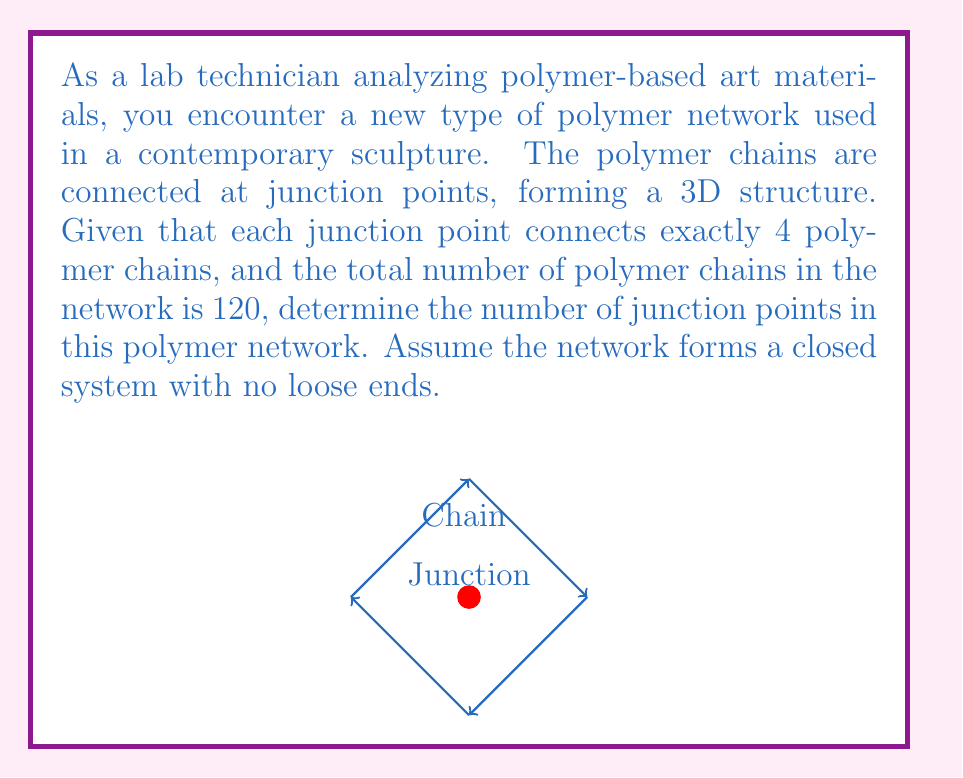Could you help me with this problem? To solve this problem, we need to use concepts from graph theory, which is closely related to topology. Let's approach this step-by-step:

1) In this polymer network, each junction point can be considered a vertex in a graph, and each polymer chain can be considered an edge.

2) Let $v$ be the number of junction points (vertices) and $e$ be the number of polymer chains (edges).

3) We're given that $e = 120$.

4) Each junction point connects exactly 4 polymer chains. In graph theory terms, this means each vertex has a degree of 4.

5) There's a fundamental relationship in graph theory known as the Handshaking Lemma, which states that the sum of the degrees of all vertices is equal to twice the number of edges. Mathematically:

   $$\sum \text{degree}(v) = 2e$$

6) In our case, since each vertex has a degree of 4, we can write:

   $$4v = 2e$$

7) Substituting the known value of $e$:

   $$4v = 2(120)$$
   $$4v = 240$$

8) Solving for $v$:

   $$v = 240 / 4 = 60$$

Therefore, there are 60 junction points in the polymer network.
Answer: 60 junction points 